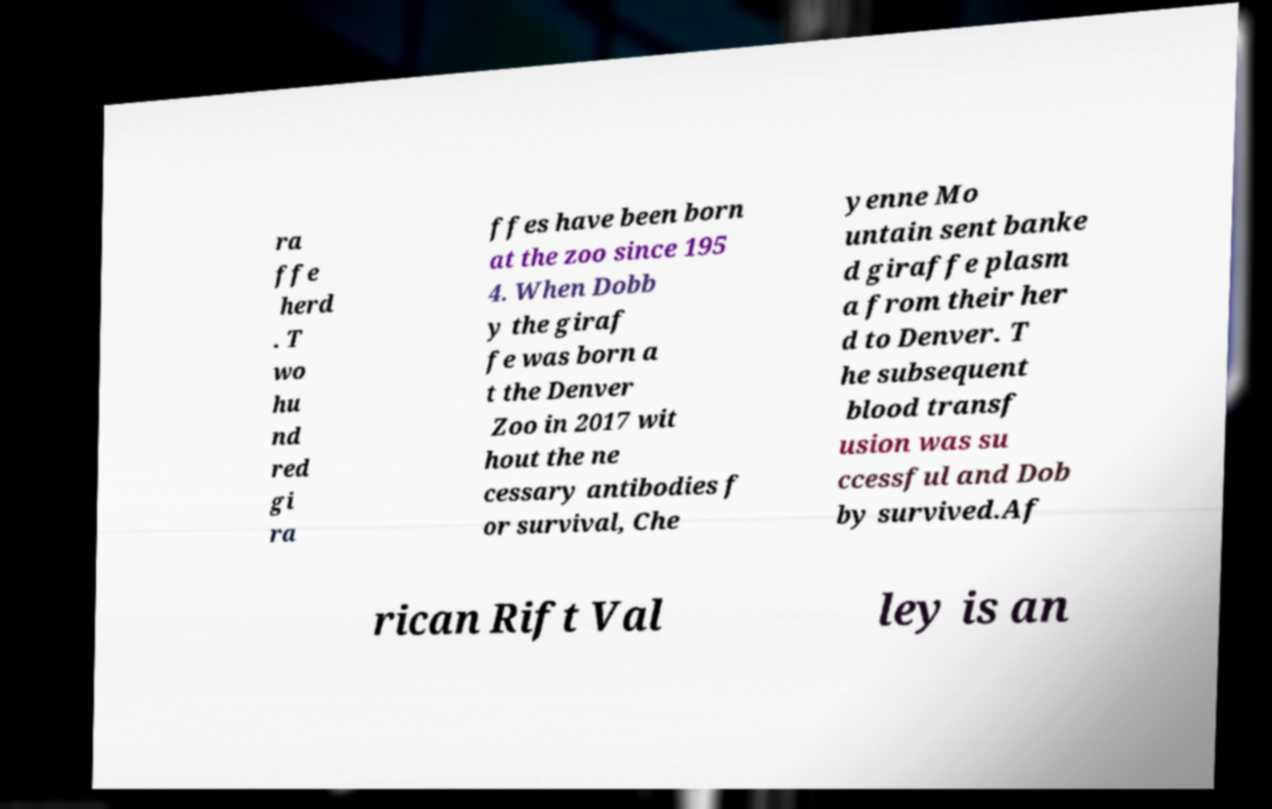Can you accurately transcribe the text from the provided image for me? ra ffe herd . T wo hu nd red gi ra ffes have been born at the zoo since 195 4. When Dobb y the giraf fe was born a t the Denver Zoo in 2017 wit hout the ne cessary antibodies f or survival, Che yenne Mo untain sent banke d giraffe plasm a from their her d to Denver. T he subsequent blood transf usion was su ccessful and Dob by survived.Af rican Rift Val ley is an 